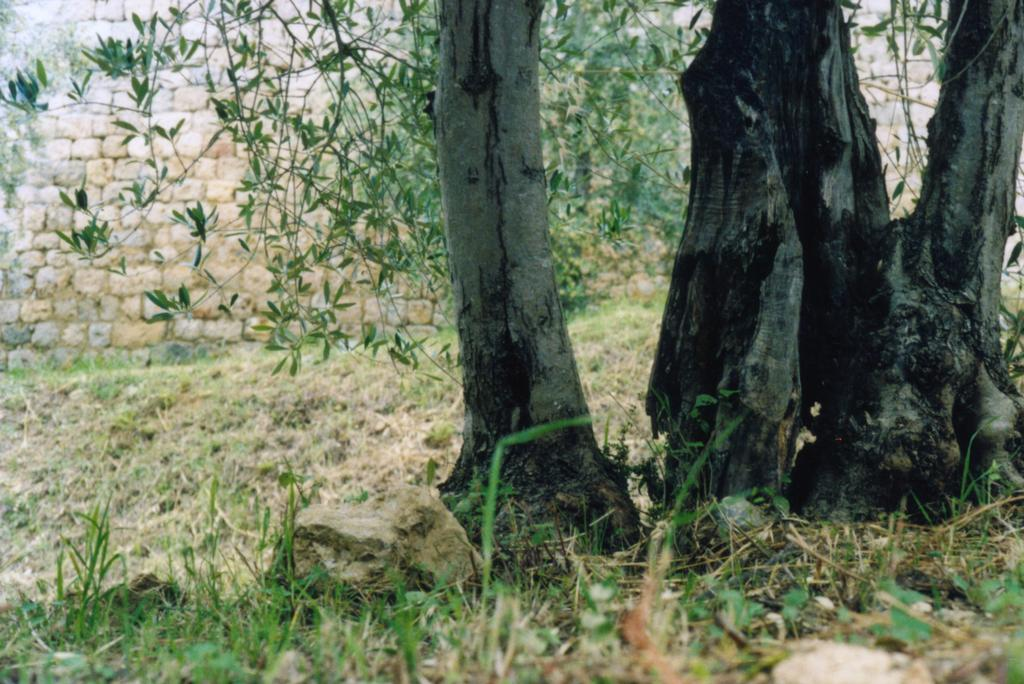What type of vegetation can be seen in the image? There are trees in the image. What is visible in the background of the image? There is a wall in the background of the image. What type of ground cover is present in the image? Grass is present on the ground in the image. What other objects can be seen on the ground in the image? Rocks are visible on the ground in the image. What type of hammer is being played as an instrument in the image? There is no hammer or instrument present in the image. Where is the pocket located in the image? There is no pocket present in the image. 